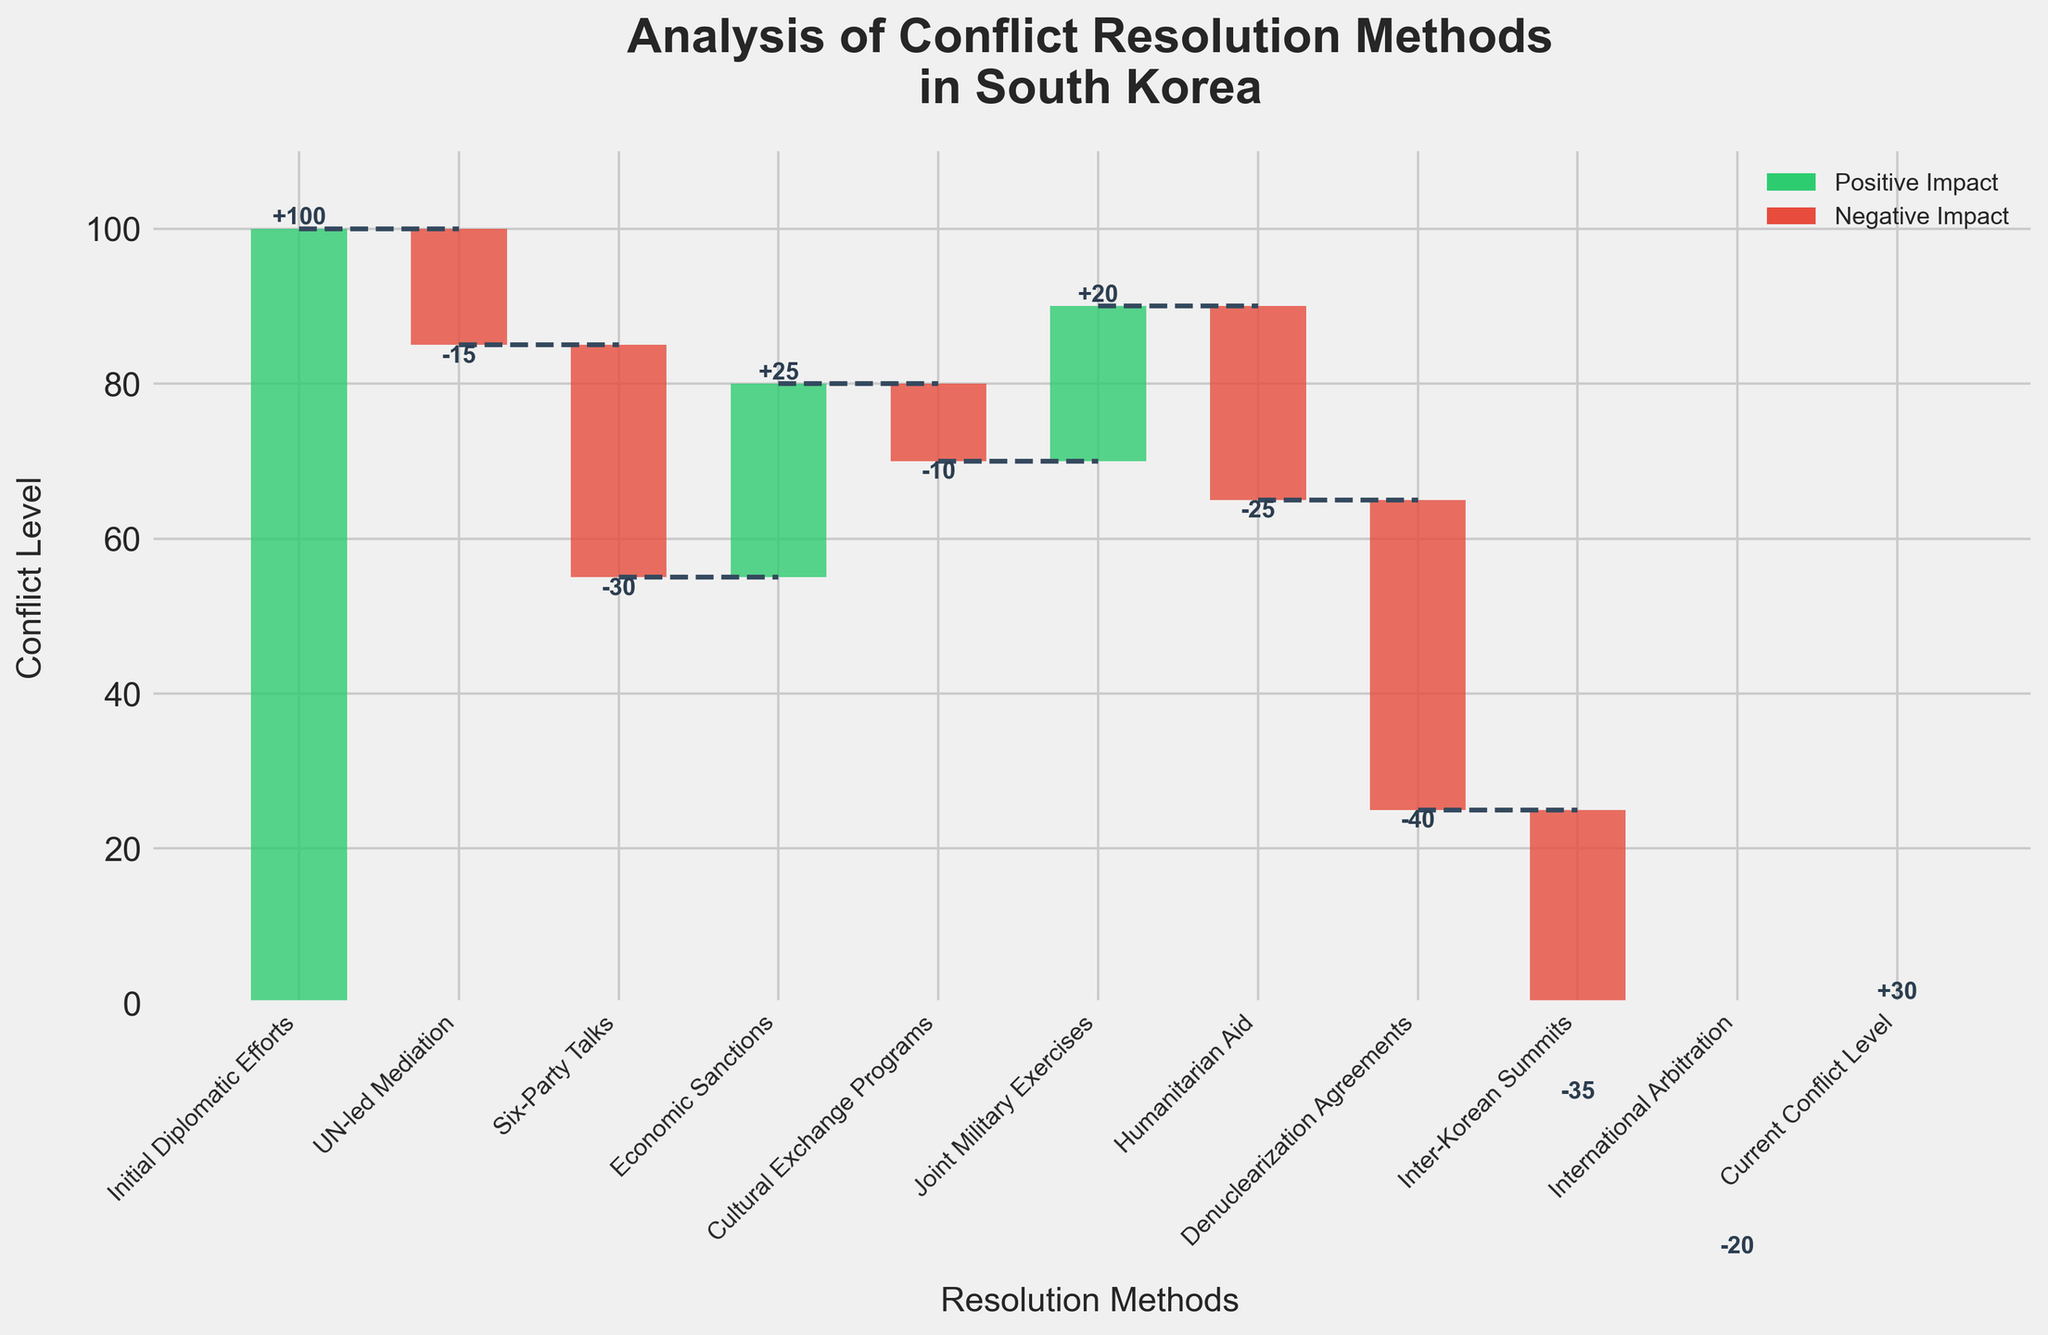What is the title of the chart? The chart's title is displayed at the top. It reads "Analysis of Conflict Resolution Methods in South Korea."
Answer: Analysis of Conflict Resolution Methods in South Korea How many categories of conflict resolution methods are shown in the chart? By counting the total number of bars along the x-axis, we see that there are 11 categories listed.
Answer: 11 Which method has the highest positive impact on conflict resolution? The tallest green bar signifies the method with the highest positive impact, which corresponds to "Economic Sanctions" with a value of +25.
Answer: Economic Sanctions What is the range of the conflict level values shown on the y-axis? The y-axis ranges from 0 to a bit above 150%, as evident from the y-axis labels and the bar heights.
Answer: 0 to ~150 How does the impact of "Joint Military Exercises" compare to "UN-led Mediation"? The bar for "Joint Military Exercises" is green and higher, indicating a positive impact of +20, whereas "UN-led Mediation" is red with a negative impact of -15. Thus, "Joint Military Exercises" has a greater positive impact.
Answer: Joint Military Exercises has a greater impact What is the total negative impact of all methods combined? Sum the values of all red bars: -15 (UN-led Mediation) + -30 (Six-Party Talks) + -10 (Cultural Exchange Programs) + -25 (Humanitarian Aid) + -40 (Denuclearization Agreements) + -35 (Inter-Korean Summits) + -20 (International Arbitration) = -175.
Answer: -175 What is the cumulative impact on conflict levels at the end, considering all methods? The last labelled bar, "Current Conflict Level," shows the resultant level after all methods are considered, which is indicated with a value of 30.
Answer: 30 Which method decreased the conflict levels the most? The bar with the greatest negative value is "Denuclearization Agreements," as indicated by the longest red bar with a value of -40.
Answer: Denuclearization Agreements What is the net effect of "Economic Sanctions" and "Humanitarian Aid" on conflict levels? "Economic Sanctions" has a positive impact (+25) and "Humanitarian Aid" has a negative impact (-25). Their net effect is 25 + (-25) = 0.
Answer: 0 What is the change in conflict level from the initial diplomatic efforts to the current level? Start with the initial value (100) and follow the cumulative steps through each resolution method, resulting in a final value of 30. The change is hence 30 - 100 = -70.
Answer: -70 